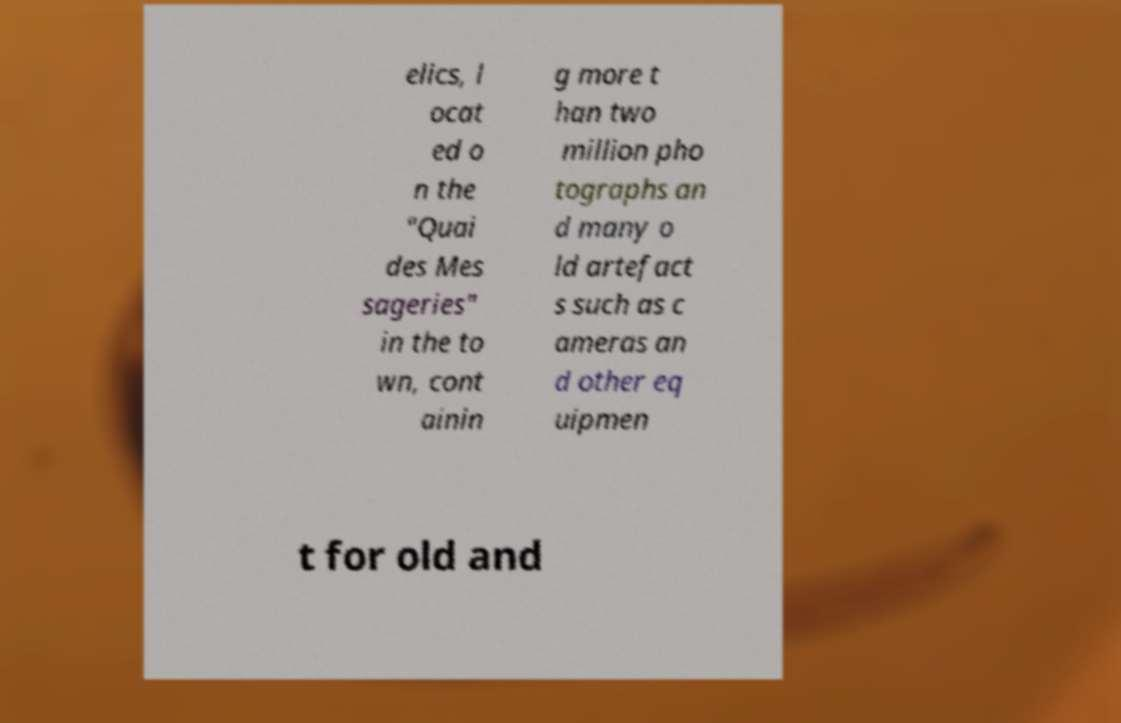What messages or text are displayed in this image? I need them in a readable, typed format. elics, l ocat ed o n the "Quai des Mes sageries" in the to wn, cont ainin g more t han two million pho tographs an d many o ld artefact s such as c ameras an d other eq uipmen t for old and 